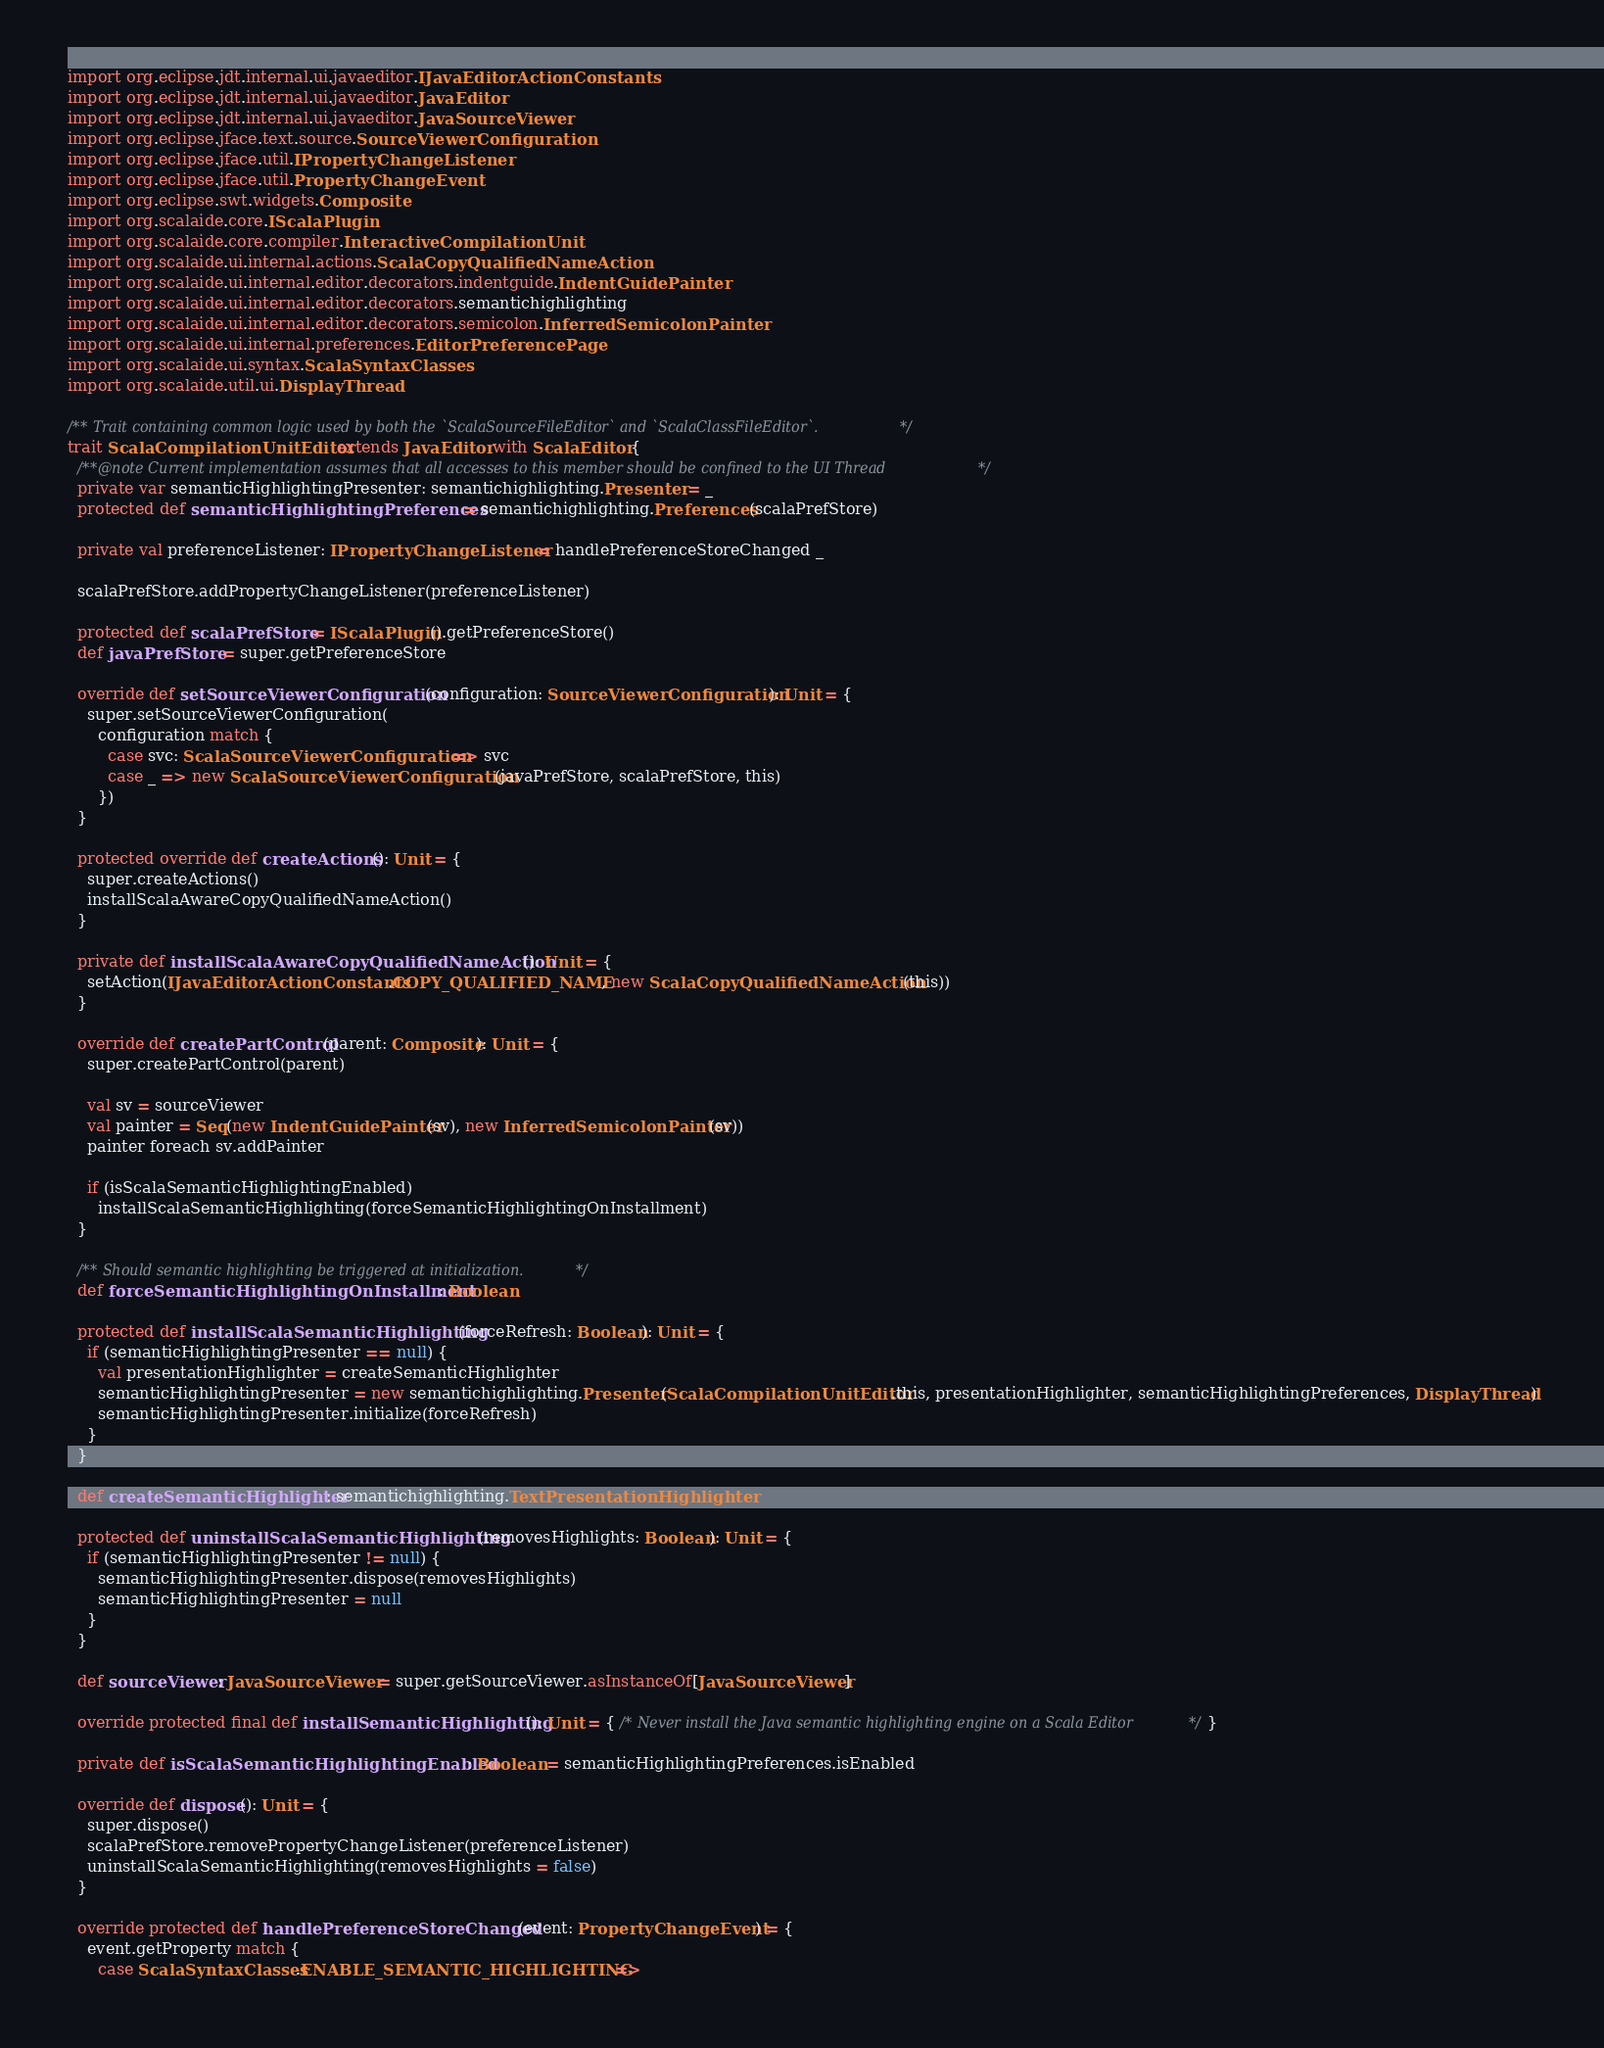<code> <loc_0><loc_0><loc_500><loc_500><_Scala_>import org.eclipse.jdt.internal.ui.javaeditor.IJavaEditorActionConstants
import org.eclipse.jdt.internal.ui.javaeditor.JavaEditor
import org.eclipse.jdt.internal.ui.javaeditor.JavaSourceViewer
import org.eclipse.jface.text.source.SourceViewerConfiguration
import org.eclipse.jface.util.IPropertyChangeListener
import org.eclipse.jface.util.PropertyChangeEvent
import org.eclipse.swt.widgets.Composite
import org.scalaide.core.IScalaPlugin
import org.scalaide.core.compiler.InteractiveCompilationUnit
import org.scalaide.ui.internal.actions.ScalaCopyQualifiedNameAction
import org.scalaide.ui.internal.editor.decorators.indentguide.IndentGuidePainter
import org.scalaide.ui.internal.editor.decorators.semantichighlighting
import org.scalaide.ui.internal.editor.decorators.semicolon.InferredSemicolonPainter
import org.scalaide.ui.internal.preferences.EditorPreferencePage
import org.scalaide.ui.syntax.ScalaSyntaxClasses
import org.scalaide.util.ui.DisplayThread

/** Trait containing common logic used by both the `ScalaSourceFileEditor` and `ScalaClassFileEditor`.*/
trait ScalaCompilationUnitEditor extends JavaEditor with ScalaEditor {
  /**@note Current implementation assumes that all accesses to this member should be confined to the UI Thread */
  private var semanticHighlightingPresenter: semantichighlighting.Presenter = _
  protected def semanticHighlightingPreferences = semantichighlighting.Preferences(scalaPrefStore)

  private val preferenceListener: IPropertyChangeListener = handlePreferenceStoreChanged _

  scalaPrefStore.addPropertyChangeListener(preferenceListener)

  protected def scalaPrefStore = IScalaPlugin().getPreferenceStore()
  def javaPrefStore = super.getPreferenceStore

  override def setSourceViewerConfiguration(configuration: SourceViewerConfiguration): Unit = {
    super.setSourceViewerConfiguration(
      configuration match {
        case svc: ScalaSourceViewerConfiguration => svc
        case _ => new ScalaSourceViewerConfiguration(javaPrefStore, scalaPrefStore, this)
      })
  }

  protected override def createActions(): Unit = {
    super.createActions()
    installScalaAwareCopyQualifiedNameAction()
  }

  private def installScalaAwareCopyQualifiedNameAction(): Unit = {
    setAction(IJavaEditorActionConstants.COPY_QUALIFIED_NAME, new ScalaCopyQualifiedNameAction(this))
  }

  override def createPartControl(parent: Composite): Unit = {
    super.createPartControl(parent)

    val sv = sourceViewer
    val painter = Seq(new IndentGuidePainter(sv), new InferredSemicolonPainter(sv))
    painter foreach sv.addPainter

    if (isScalaSemanticHighlightingEnabled)
      installScalaSemanticHighlighting(forceSemanticHighlightingOnInstallment)
  }

  /** Should semantic highlighting be triggered at initialization. */
  def forceSemanticHighlightingOnInstallment: Boolean

  protected def installScalaSemanticHighlighting(forceRefresh: Boolean): Unit = {
    if (semanticHighlightingPresenter == null) {
      val presentationHighlighter = createSemanticHighlighter
      semanticHighlightingPresenter = new semantichighlighting.Presenter(ScalaCompilationUnitEditor.this, presentationHighlighter, semanticHighlightingPreferences, DisplayThread)
      semanticHighlightingPresenter.initialize(forceRefresh)
    }
  }

  def createSemanticHighlighter: semantichighlighting.TextPresentationHighlighter

  protected def uninstallScalaSemanticHighlighting(removesHighlights: Boolean): Unit = {
    if (semanticHighlightingPresenter != null) {
      semanticHighlightingPresenter.dispose(removesHighlights)
      semanticHighlightingPresenter = null
    }
  }

  def sourceViewer: JavaSourceViewer = super.getSourceViewer.asInstanceOf[JavaSourceViewer]

  override protected final def installSemanticHighlighting(): Unit = { /* Never install the Java semantic highlighting engine on a Scala Editor*/ }

  private def isScalaSemanticHighlightingEnabled: Boolean = semanticHighlightingPreferences.isEnabled

  override def dispose(): Unit = {
    super.dispose()
    scalaPrefStore.removePropertyChangeListener(preferenceListener)
    uninstallScalaSemanticHighlighting(removesHighlights = false)
  }

  override protected def handlePreferenceStoreChanged(event: PropertyChangeEvent) = {
    event.getProperty match {
      case ScalaSyntaxClasses.ENABLE_SEMANTIC_HIGHLIGHTING =></code> 